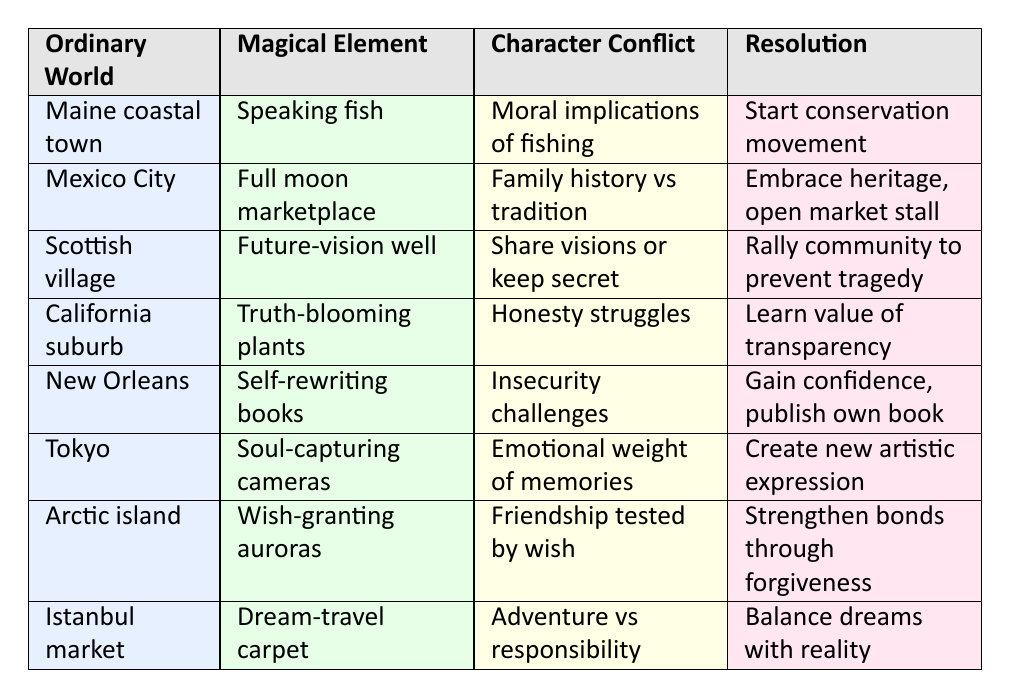What is the magical element in the scenario set in a small coastal town in Maine? Referring to the table, the magical element associated with the scenario about the small coastal town in Maine is "Fish that can speak human languages." This information can be directly retrieved from the corresponding row in the table.
Answer: Fish that can speak human languages In which ordinary world does the character conflict involve a young woman discovering her family’s history? By examining the table, the character conflict regarding a young woman discovering her family’s history is found in the scenario set in "A bustling city in Mexico City." This is confirmed in the second row.
Answer: A bustling city in Mexico City True or False: The character in the scenario from a suburban neighborhood in California learns the value of self-acceptance. In the table, the resolution of the character conflict in the California suburb scenario indicates that the teenager learns the value of transparency and self-acceptance through honest conversations. Therefore, this statement is true.
Answer: True What resolution does the elderly villager choose after witnessing a tragic future? The table specifies that the resolution for the scenario in a sleepy village in Scotland involves the elderly villager deciding to rally the community to prevent the tragic future after witnessing it. This can be found in the corresponding entry.
Answer: Rally the community to prevent tragedy Among the provided scenarios, how many involve a character struggling with family or societal expectations? Reviewing the table, two scenarios clearly involve characters struggling with family or societal expectations: the scenario in Mexico City (young woman vs. traditionalist parents) and the California suburb (teenager facing pressures from peers and family). Thus, the total is 2.
Answer: 2 